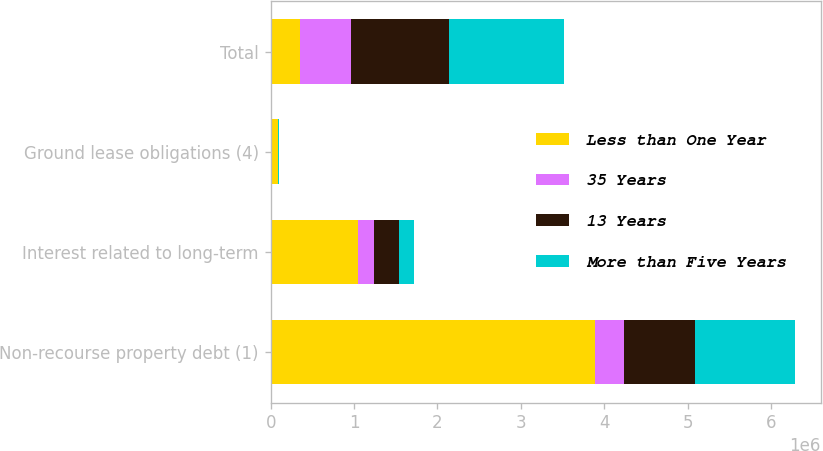<chart> <loc_0><loc_0><loc_500><loc_500><stacked_bar_chart><ecel><fcel>Non-recourse property debt (1)<fcel>Interest related to long-term<fcel>Ground lease obligations (4)<fcel>Total<nl><fcel>Less than One Year<fcel>3.88965e+06<fcel>1.05244e+06<fcel>88057<fcel>346519<nl><fcel>35 Years<fcel>346519<fcel>185303<fcel>1093<fcel>618972<nl><fcel>13 Years<fcel>856830<fcel>300991<fcel>2486<fcel>1.16782e+06<nl><fcel>More than Five Years<fcel>1.18994e+06<fcel>185360<fcel>3094<fcel>1.37855e+06<nl></chart> 